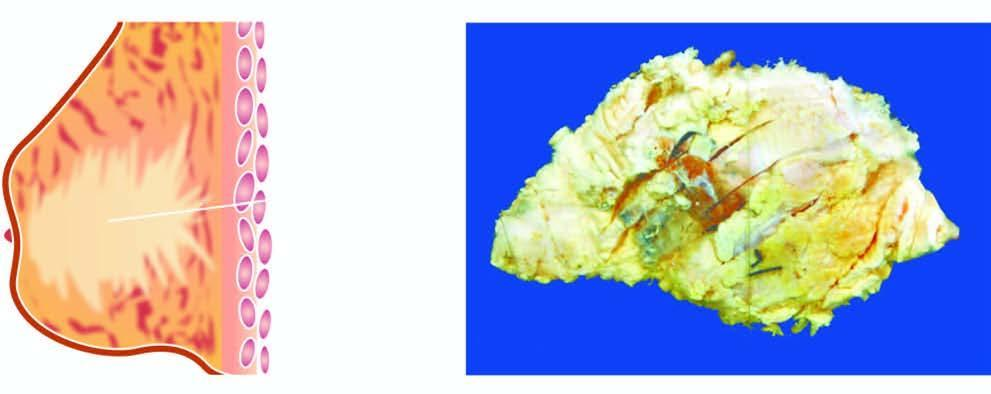does cut surface show a grey white firm tumour extending irregularly into adjacent breast parenchyma?
Answer the question using a single word or phrase. Yes 